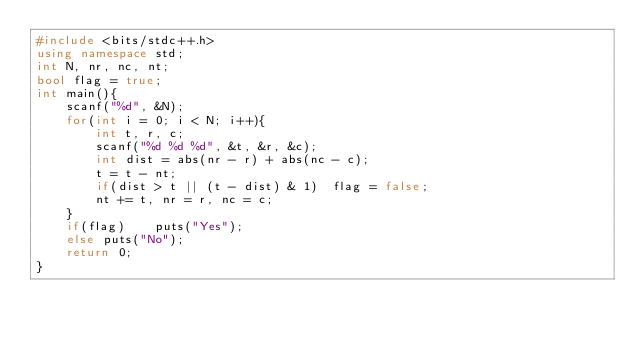Convert code to text. <code><loc_0><loc_0><loc_500><loc_500><_C++_>#include <bits/stdc++.h>
using namespace std;
int N, nr, nc, nt;
bool flag = true;
int main(){
	scanf("%d", &N);
	for(int i = 0; i < N; i++){
		int t, r, c;
		scanf("%d %d %d", &t, &r, &c);
		int dist = abs(nr - r) + abs(nc - c);
		t = t - nt;
		if(dist > t || (t - dist) & 1)	flag = false;
		nt += t, nr = r, nc = c;
	}
	if(flag)	puts("Yes");
	else puts("No");
	return 0;
}</code> 